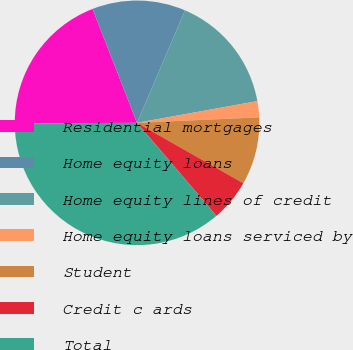<chart> <loc_0><loc_0><loc_500><loc_500><pie_chart><fcel>Residential mortgages<fcel>Home equity loans<fcel>Home equity lines of credit<fcel>Home equity loans serviced by<fcel>Student<fcel>Credit c ards<fcel>Total<nl><fcel>19.15%<fcel>12.34%<fcel>15.74%<fcel>2.13%<fcel>8.94%<fcel>5.53%<fcel>36.17%<nl></chart> 